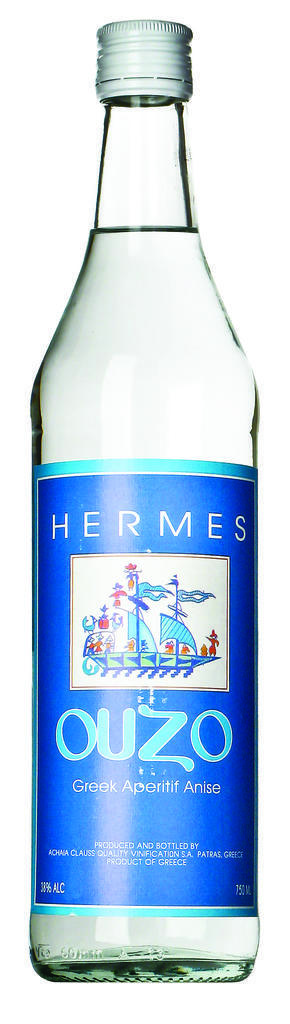What is the name of this?
Offer a terse response. Ouzo. The name is ouzo?
Your answer should be very brief. Yes. 